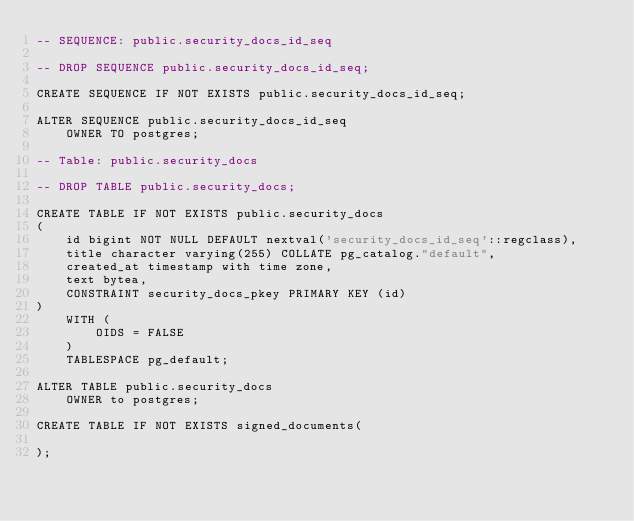<code> <loc_0><loc_0><loc_500><loc_500><_SQL_>-- SEQUENCE: public.security_docs_id_seq

-- DROP SEQUENCE public.security_docs_id_seq;

CREATE SEQUENCE IF NOT EXISTS public.security_docs_id_seq;

ALTER SEQUENCE public.security_docs_id_seq
    OWNER TO postgres;

-- Table: public.security_docs

-- DROP TABLE public.security_docs;

CREATE TABLE IF NOT EXISTS public.security_docs
(
    id bigint NOT NULL DEFAULT nextval('security_docs_id_seq'::regclass),
    title character varying(255) COLLATE pg_catalog."default",
    created_at timestamp with time zone,
    text bytea,
    CONSTRAINT security_docs_pkey PRIMARY KEY (id)
)
    WITH (
        OIDS = FALSE
    )
    TABLESPACE pg_default;

ALTER TABLE public.security_docs
    OWNER to postgres;

CREATE TABLE IF NOT EXISTS signed_documents(

);</code> 